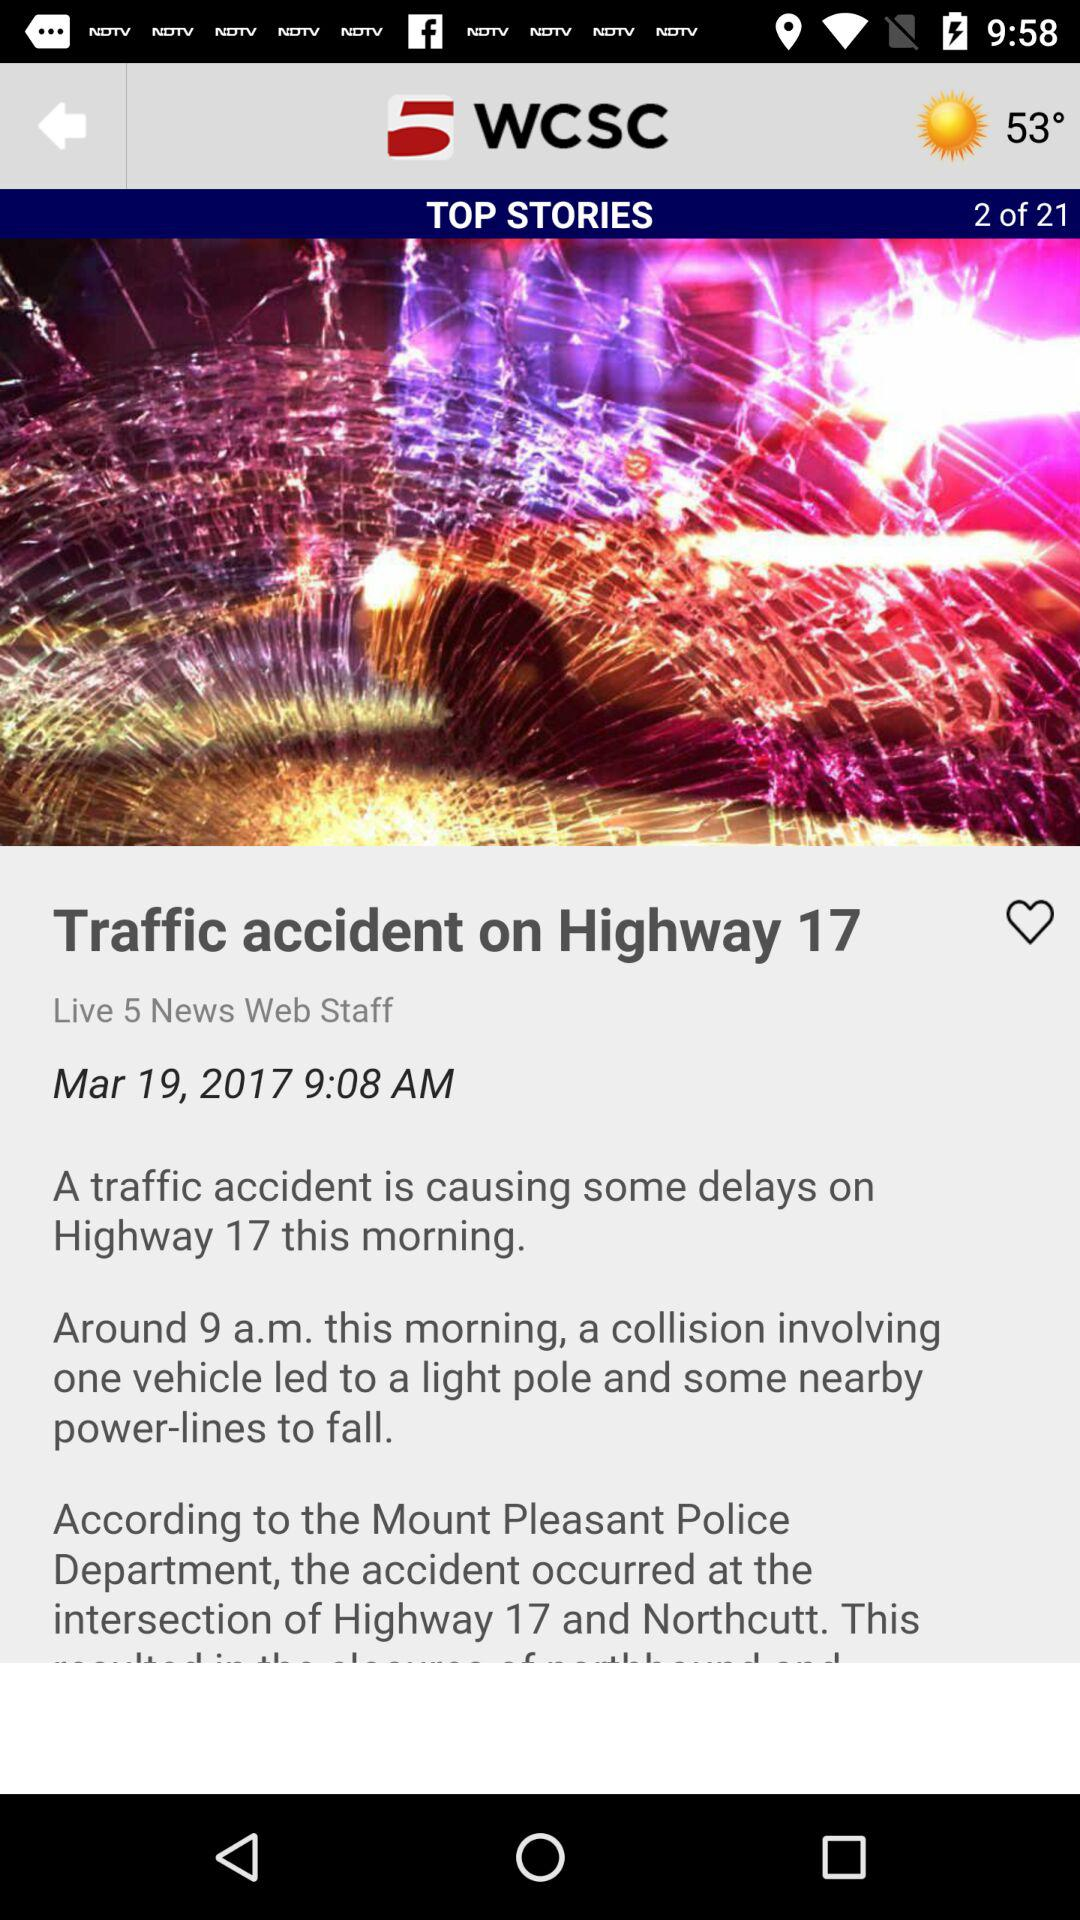What is the title of the story? The title of the story is "Traffic accident on Highway 17". 